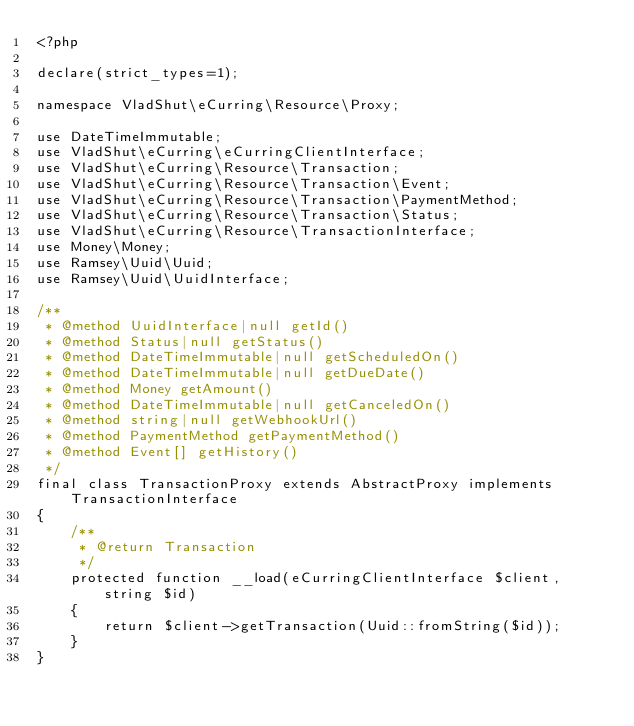Convert code to text. <code><loc_0><loc_0><loc_500><loc_500><_PHP_><?php

declare(strict_types=1);

namespace VladShut\eCurring\Resource\Proxy;

use DateTimeImmutable;
use VladShut\eCurring\eCurringClientInterface;
use VladShut\eCurring\Resource\Transaction;
use VladShut\eCurring\Resource\Transaction\Event;
use VladShut\eCurring\Resource\Transaction\PaymentMethod;
use VladShut\eCurring\Resource\Transaction\Status;
use VladShut\eCurring\Resource\TransactionInterface;
use Money\Money;
use Ramsey\Uuid\Uuid;
use Ramsey\Uuid\UuidInterface;

/**
 * @method UuidInterface|null getId()
 * @method Status|null getStatus()
 * @method DateTimeImmutable|null getScheduledOn()
 * @method DateTimeImmutable|null getDueDate()
 * @method Money getAmount()
 * @method DateTimeImmutable|null getCanceledOn()
 * @method string|null getWebhookUrl()
 * @method PaymentMethod getPaymentMethod()
 * @method Event[] getHistory()
 */
final class TransactionProxy extends AbstractProxy implements TransactionInterface
{
    /**
     * @return Transaction
     */
    protected function __load(eCurringClientInterface $client, string $id)
    {
        return $client->getTransaction(Uuid::fromString($id));
    }
}
</code> 